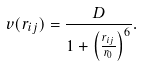Convert formula to latex. <formula><loc_0><loc_0><loc_500><loc_500>v ( r _ { i j } ) = \frac { D } { 1 + \left ( \frac { r _ { i j } } { r _ { 0 } } \right ) ^ { 6 } } .</formula> 